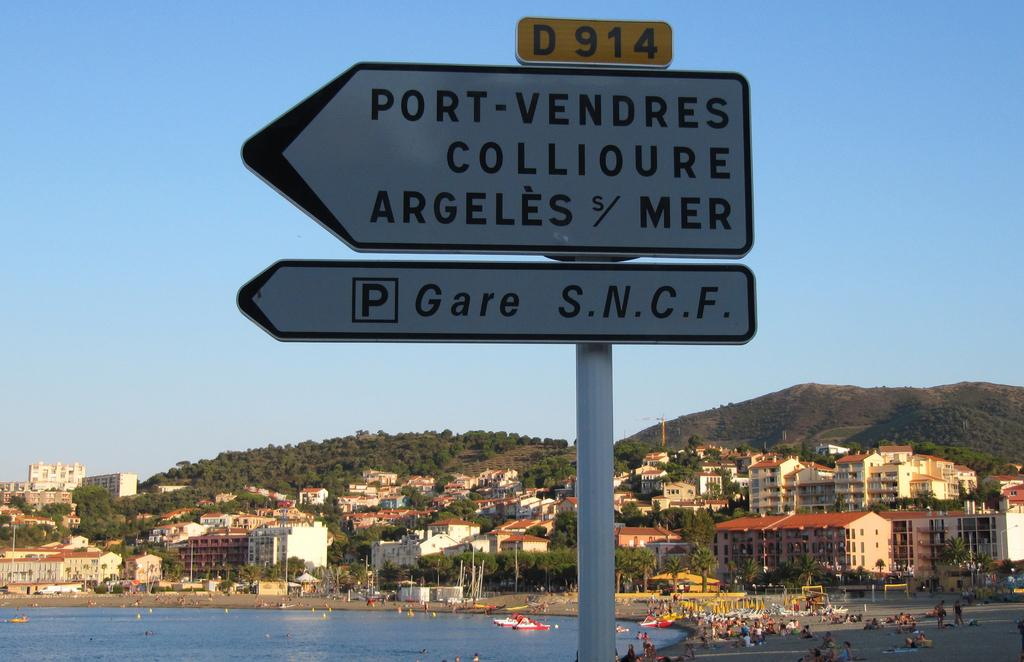<image>
Summarize the visual content of the image. A sign pointing to Port-Vendres Collioure Argeles Mer 